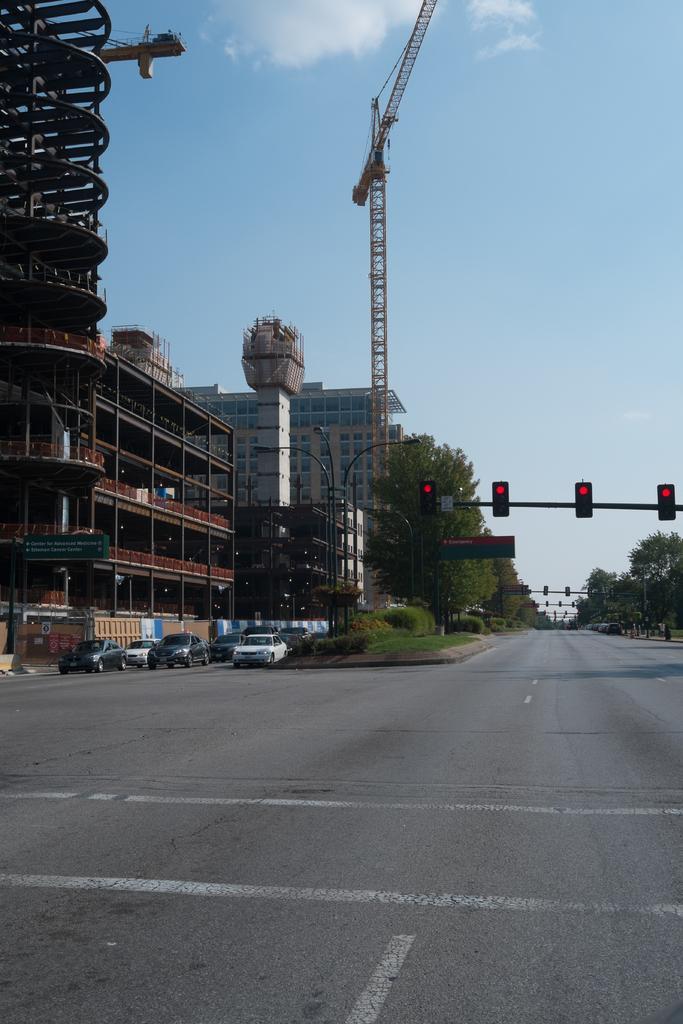Please provide a concise description of this image. In the picture we can see a road beside it, we can see grass surface and some vehicles on the road at the traffic junction, beside it, we can see construction building and beside it, we can see a building with glasses and near to it, we can see trees and on the road we can see traffic lights to the poles and in the background we can see a sky with clouds. 